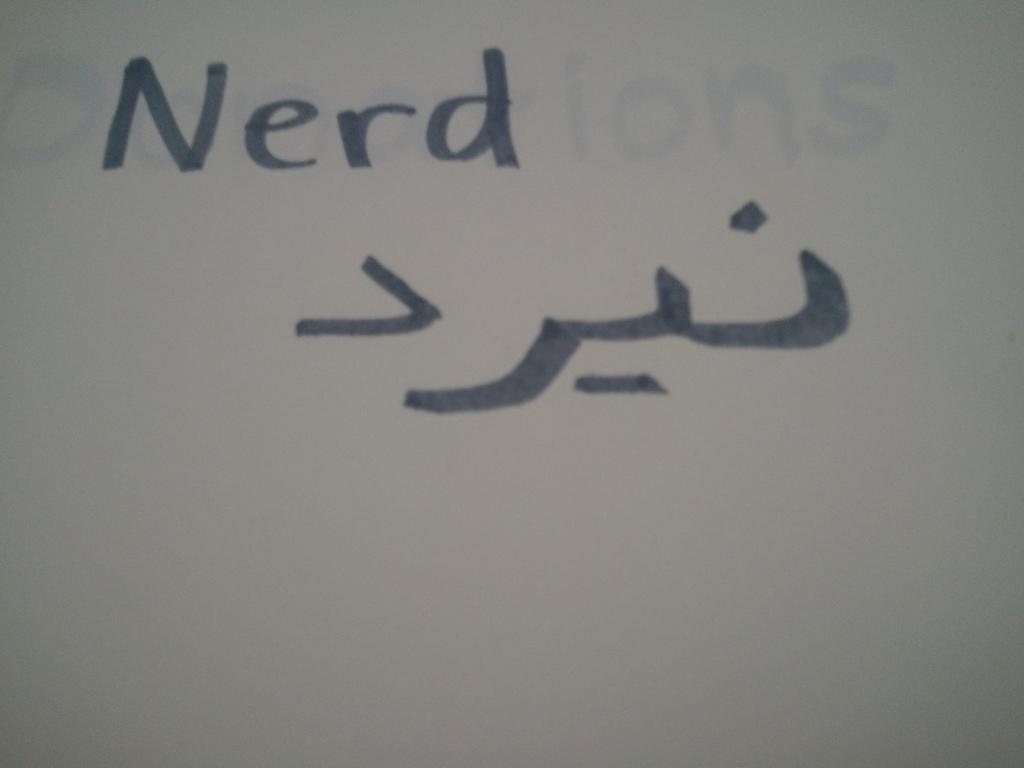<image>
Provide a brief description of the given image. A piece of paper that has Nerd written on it. 